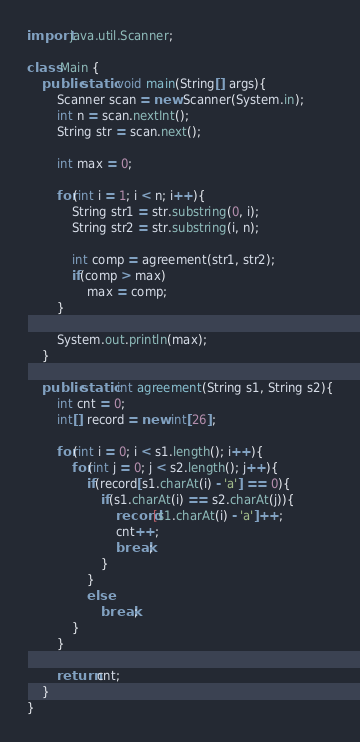Convert code to text. <code><loc_0><loc_0><loc_500><loc_500><_Java_>import java.util.Scanner;

class Main {
    public static void main(String[] args){
        Scanner scan = new Scanner(System.in);
        int n = scan.nextInt();
        String str = scan.next();

        int max = 0;

        for(int i = 1; i < n; i++){
            String str1 = str.substring(0, i);
            String str2 = str.substring(i, n);
            
            int comp = agreement(str1, str2);
            if(comp > max)
                max = comp;
        }

        System.out.println(max);
    }

    public static int agreement(String s1, String s2){
        int cnt = 0;
        int[] record = new int[26];

        for(int i = 0; i < s1.length(); i++){
            for(int j = 0; j < s2.length(); j++){
                if(record[s1.charAt(i) - 'a'] == 0){
                    if(s1.charAt(i) == s2.charAt(j)){
                        record[s1.charAt(i) - 'a']++;
                        cnt++;
                        break;
                    }
                }
                else
                    break;
            }
        }
        
        return cnt;
    }  
}</code> 